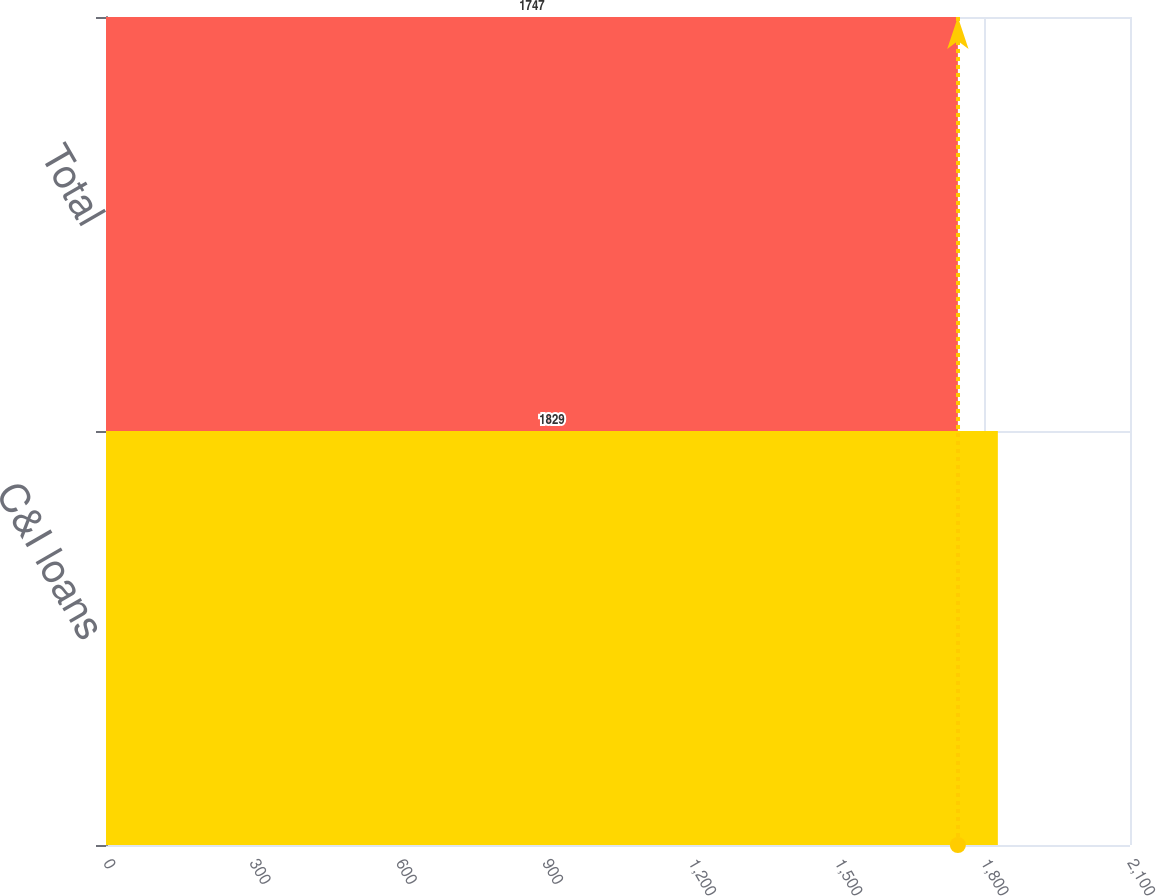Convert chart to OTSL. <chart><loc_0><loc_0><loc_500><loc_500><bar_chart><fcel>C&I loans<fcel>Total<nl><fcel>1829<fcel>1747<nl></chart> 